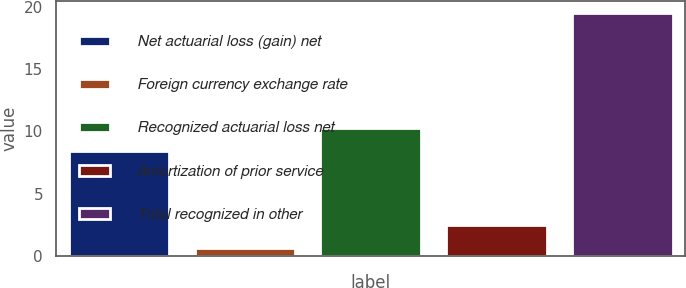Convert chart. <chart><loc_0><loc_0><loc_500><loc_500><bar_chart><fcel>Net actuarial loss (gain) net<fcel>Foreign currency exchange rate<fcel>Recognized actuarial loss net<fcel>Amortization of prior service<fcel>Total recognized in other<nl><fcel>8.4<fcel>0.6<fcel>10.29<fcel>2.49<fcel>19.5<nl></chart> 